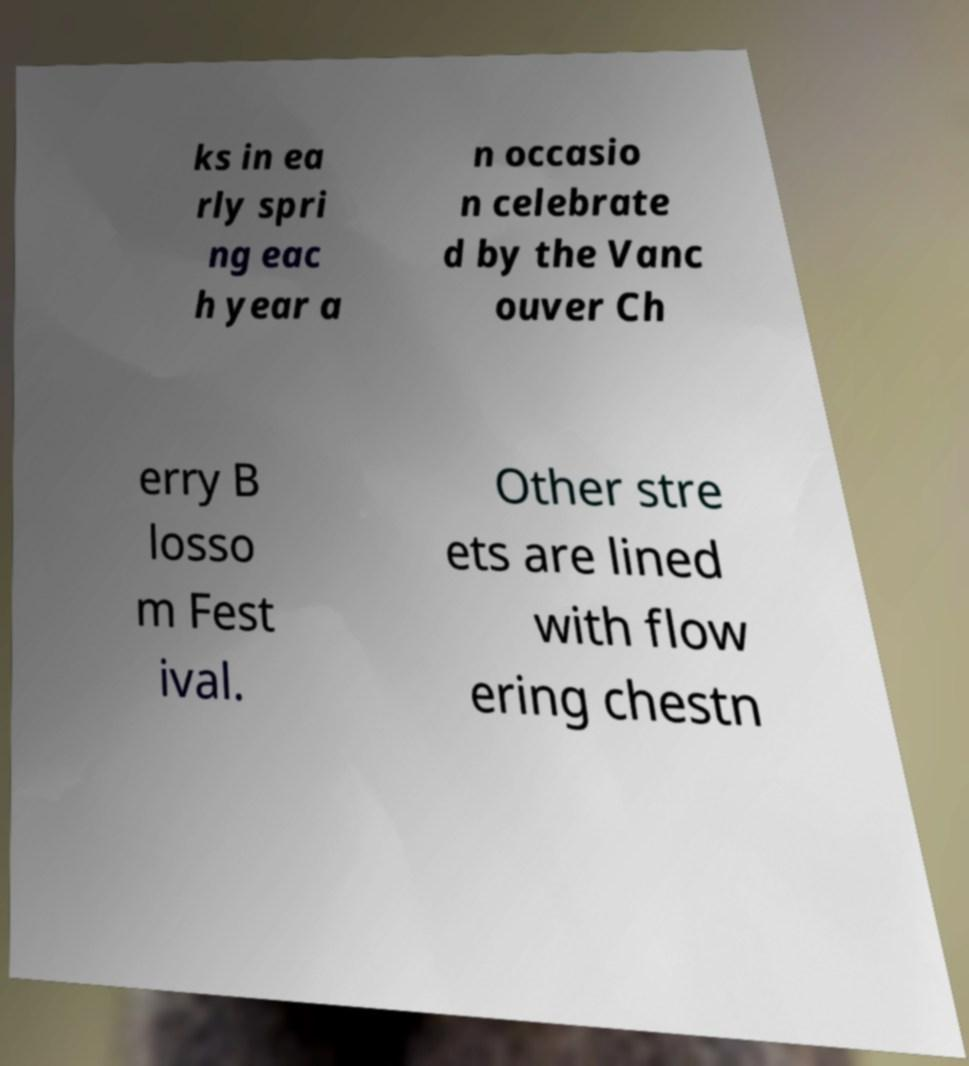Can you accurately transcribe the text from the provided image for me? ks in ea rly spri ng eac h year a n occasio n celebrate d by the Vanc ouver Ch erry B losso m Fest ival. Other stre ets are lined with flow ering chestn 